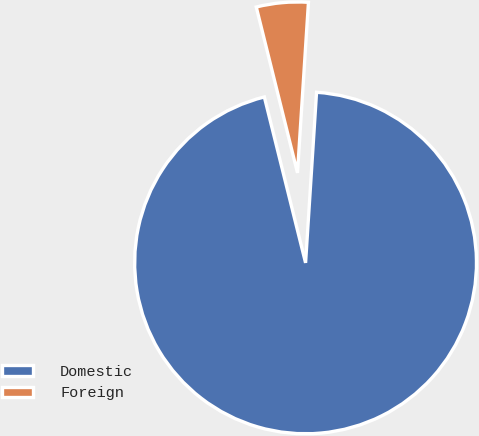Convert chart to OTSL. <chart><loc_0><loc_0><loc_500><loc_500><pie_chart><fcel>Domestic<fcel>Foreign<nl><fcel>95.1%<fcel>4.9%<nl></chart> 